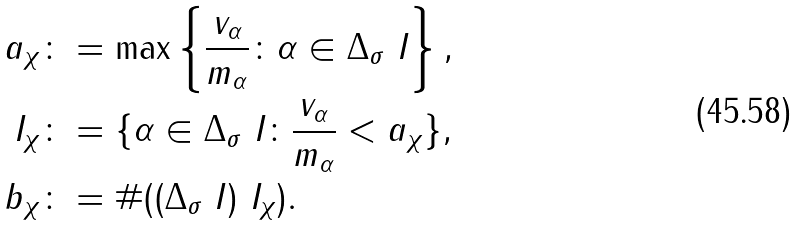Convert formula to latex. <formula><loc_0><loc_0><loc_500><loc_500>a _ { \chi } & \colon = \max \left \{ \frac { v _ { \alpha } } { m _ { \alpha } } \colon \alpha \in \Delta _ { \sigma } \ I \right \} , \\ I _ { \chi } & \colon = \{ \alpha \in \Delta _ { \sigma } \ I \colon \frac { v _ { \alpha } } { m _ { \alpha } } < a _ { \chi } \} , \\ b _ { \chi } & \colon = \# ( ( \Delta _ { \sigma } \ I ) \ I _ { \chi } ) .</formula> 